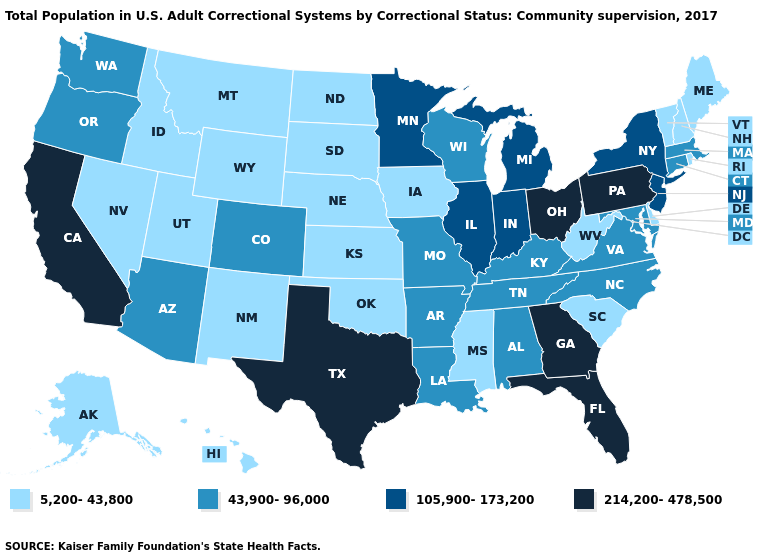What is the value of Hawaii?
Quick response, please. 5,200-43,800. Does Pennsylvania have the lowest value in the Northeast?
Write a very short answer. No. Does Texas have the highest value in the South?
Give a very brief answer. Yes. How many symbols are there in the legend?
Short answer required. 4. What is the value of Pennsylvania?
Be succinct. 214,200-478,500. Among the states that border New Jersey , which have the highest value?
Answer briefly. Pennsylvania. Name the states that have a value in the range 105,900-173,200?
Concise answer only. Illinois, Indiana, Michigan, Minnesota, New Jersey, New York. Name the states that have a value in the range 5,200-43,800?
Concise answer only. Alaska, Delaware, Hawaii, Idaho, Iowa, Kansas, Maine, Mississippi, Montana, Nebraska, Nevada, New Hampshire, New Mexico, North Dakota, Oklahoma, Rhode Island, South Carolina, South Dakota, Utah, Vermont, West Virginia, Wyoming. Does Maryland have the same value as Kentucky?
Answer briefly. Yes. Which states have the lowest value in the USA?
Give a very brief answer. Alaska, Delaware, Hawaii, Idaho, Iowa, Kansas, Maine, Mississippi, Montana, Nebraska, Nevada, New Hampshire, New Mexico, North Dakota, Oklahoma, Rhode Island, South Carolina, South Dakota, Utah, Vermont, West Virginia, Wyoming. What is the highest value in the USA?
Short answer required. 214,200-478,500. Which states have the highest value in the USA?
Give a very brief answer. California, Florida, Georgia, Ohio, Pennsylvania, Texas. Among the states that border Missouri , which have the highest value?
Short answer required. Illinois. Which states have the lowest value in the USA?
Short answer required. Alaska, Delaware, Hawaii, Idaho, Iowa, Kansas, Maine, Mississippi, Montana, Nebraska, Nevada, New Hampshire, New Mexico, North Dakota, Oklahoma, Rhode Island, South Carolina, South Dakota, Utah, Vermont, West Virginia, Wyoming. Does Delaware have the lowest value in the South?
Answer briefly. Yes. 